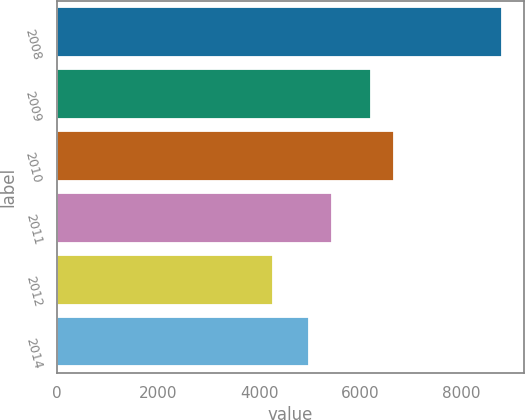Convert chart. <chart><loc_0><loc_0><loc_500><loc_500><bar_chart><fcel>2008<fcel>2009<fcel>2010<fcel>2011<fcel>2012<fcel>2014<nl><fcel>8788<fcel>6204<fcel>6656.3<fcel>5440.3<fcel>4265<fcel>4988<nl></chart> 